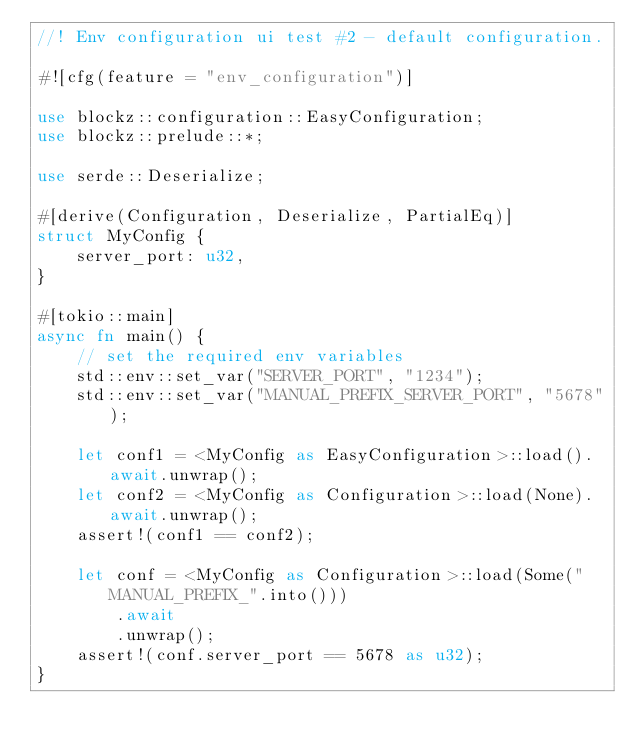Convert code to text. <code><loc_0><loc_0><loc_500><loc_500><_Rust_>//! Env configuration ui test #2 - default configuration.

#![cfg(feature = "env_configuration")]

use blockz::configuration::EasyConfiguration;
use blockz::prelude::*;

use serde::Deserialize;

#[derive(Configuration, Deserialize, PartialEq)]
struct MyConfig {
    server_port: u32,
}

#[tokio::main]
async fn main() {
    // set the required env variables
    std::env::set_var("SERVER_PORT", "1234");
    std::env::set_var("MANUAL_PREFIX_SERVER_PORT", "5678");

    let conf1 = <MyConfig as EasyConfiguration>::load().await.unwrap();
    let conf2 = <MyConfig as Configuration>::load(None).await.unwrap();
    assert!(conf1 == conf2);

    let conf = <MyConfig as Configuration>::load(Some("MANUAL_PREFIX_".into()))
        .await
        .unwrap();
    assert!(conf.server_port == 5678 as u32);
}
</code> 